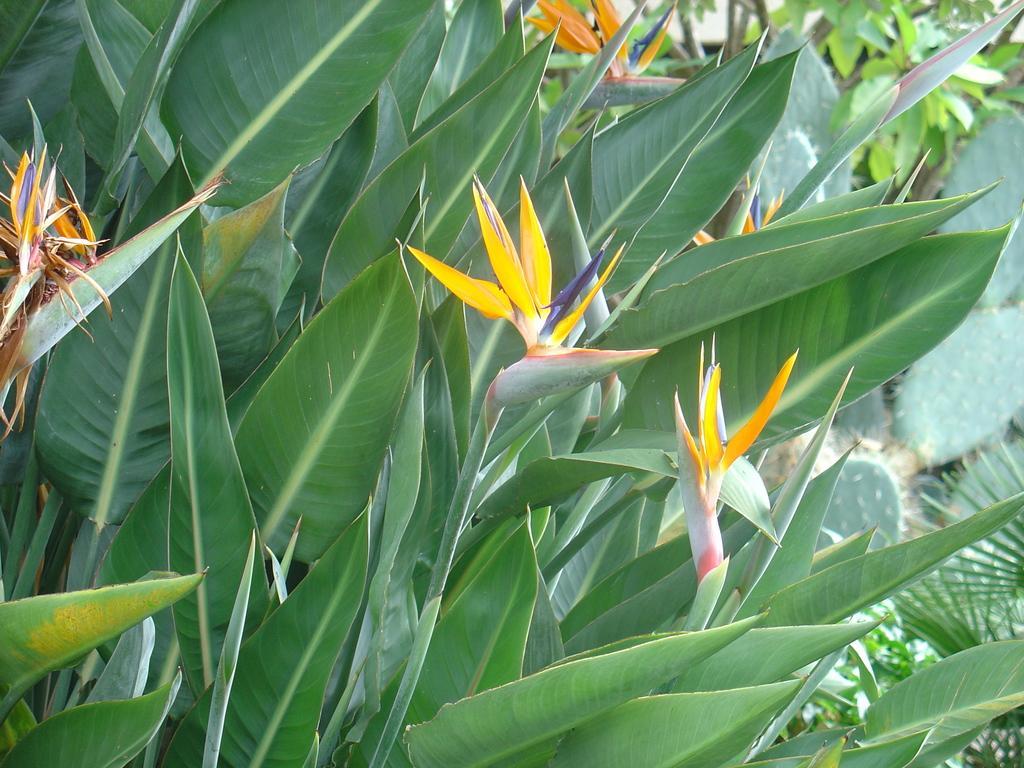How would you summarize this image in a sentence or two? In this image I can see plants. 